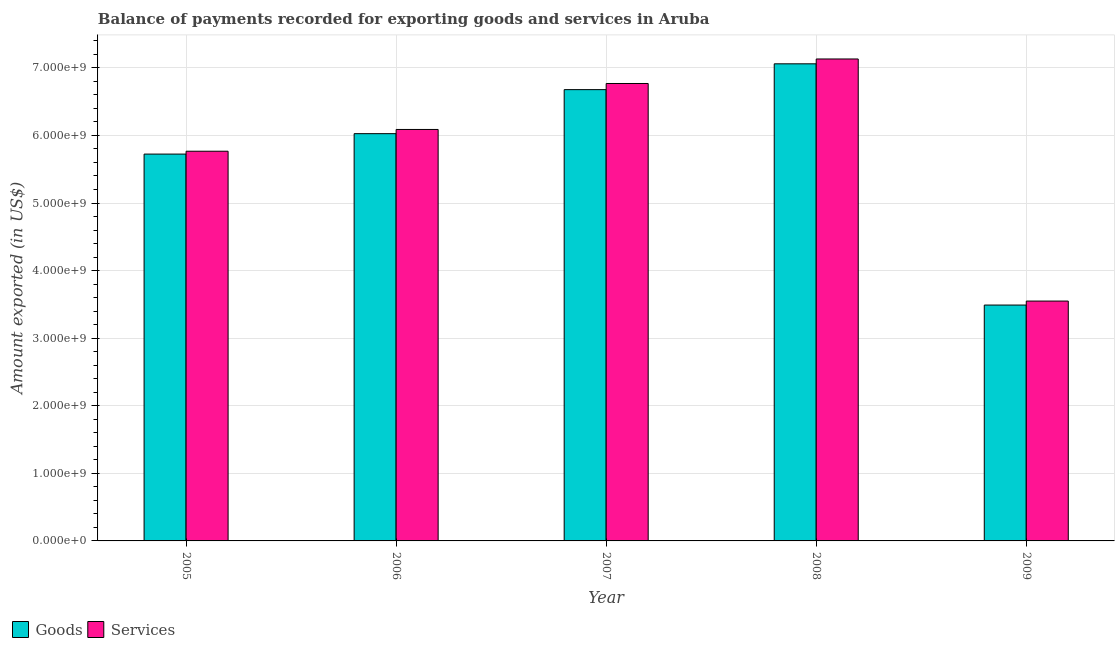How many groups of bars are there?
Give a very brief answer. 5. What is the label of the 3rd group of bars from the left?
Give a very brief answer. 2007. In how many cases, is the number of bars for a given year not equal to the number of legend labels?
Your answer should be compact. 0. What is the amount of services exported in 2008?
Give a very brief answer. 7.13e+09. Across all years, what is the maximum amount of services exported?
Your answer should be compact. 7.13e+09. Across all years, what is the minimum amount of services exported?
Ensure brevity in your answer.  3.55e+09. In which year was the amount of services exported minimum?
Your response must be concise. 2009. What is the total amount of goods exported in the graph?
Ensure brevity in your answer.  2.90e+1. What is the difference between the amount of goods exported in 2005 and that in 2006?
Your answer should be compact. -3.02e+08. What is the difference between the amount of services exported in 2005 and the amount of goods exported in 2008?
Provide a short and direct response. -1.37e+09. What is the average amount of goods exported per year?
Make the answer very short. 5.80e+09. In the year 2007, what is the difference between the amount of services exported and amount of goods exported?
Offer a very short reply. 0. What is the ratio of the amount of goods exported in 2005 to that in 2006?
Ensure brevity in your answer.  0.95. Is the amount of goods exported in 2008 less than that in 2009?
Provide a short and direct response. No. What is the difference between the highest and the second highest amount of goods exported?
Your answer should be very brief. 3.82e+08. What is the difference between the highest and the lowest amount of services exported?
Make the answer very short. 3.58e+09. In how many years, is the amount of services exported greater than the average amount of services exported taken over all years?
Offer a terse response. 3. Is the sum of the amount of goods exported in 2007 and 2009 greater than the maximum amount of services exported across all years?
Your response must be concise. Yes. What does the 2nd bar from the left in 2008 represents?
Keep it short and to the point. Services. What does the 1st bar from the right in 2005 represents?
Keep it short and to the point. Services. How many bars are there?
Your answer should be very brief. 10. Are all the bars in the graph horizontal?
Provide a succinct answer. No. What is the difference between two consecutive major ticks on the Y-axis?
Your answer should be very brief. 1.00e+09. Are the values on the major ticks of Y-axis written in scientific E-notation?
Offer a terse response. Yes. Does the graph contain any zero values?
Provide a short and direct response. No. Does the graph contain grids?
Provide a succinct answer. Yes. Where does the legend appear in the graph?
Offer a very short reply. Bottom left. What is the title of the graph?
Make the answer very short. Balance of payments recorded for exporting goods and services in Aruba. Does "Private creditors" appear as one of the legend labels in the graph?
Offer a terse response. No. What is the label or title of the X-axis?
Your answer should be very brief. Year. What is the label or title of the Y-axis?
Make the answer very short. Amount exported (in US$). What is the Amount exported (in US$) of Goods in 2005?
Offer a very short reply. 5.72e+09. What is the Amount exported (in US$) in Services in 2005?
Ensure brevity in your answer.  5.77e+09. What is the Amount exported (in US$) of Goods in 2006?
Your answer should be very brief. 6.03e+09. What is the Amount exported (in US$) of Services in 2006?
Your response must be concise. 6.09e+09. What is the Amount exported (in US$) of Goods in 2007?
Your response must be concise. 6.68e+09. What is the Amount exported (in US$) in Services in 2007?
Make the answer very short. 6.77e+09. What is the Amount exported (in US$) of Goods in 2008?
Keep it short and to the point. 7.06e+09. What is the Amount exported (in US$) in Services in 2008?
Provide a succinct answer. 7.13e+09. What is the Amount exported (in US$) in Goods in 2009?
Give a very brief answer. 3.49e+09. What is the Amount exported (in US$) in Services in 2009?
Your response must be concise. 3.55e+09. Across all years, what is the maximum Amount exported (in US$) in Goods?
Give a very brief answer. 7.06e+09. Across all years, what is the maximum Amount exported (in US$) of Services?
Ensure brevity in your answer.  7.13e+09. Across all years, what is the minimum Amount exported (in US$) of Goods?
Your response must be concise. 3.49e+09. Across all years, what is the minimum Amount exported (in US$) in Services?
Offer a very short reply. 3.55e+09. What is the total Amount exported (in US$) of Goods in the graph?
Your response must be concise. 2.90e+1. What is the total Amount exported (in US$) of Services in the graph?
Ensure brevity in your answer.  2.93e+1. What is the difference between the Amount exported (in US$) of Goods in 2005 and that in 2006?
Offer a very short reply. -3.02e+08. What is the difference between the Amount exported (in US$) of Services in 2005 and that in 2006?
Provide a short and direct response. -3.22e+08. What is the difference between the Amount exported (in US$) in Goods in 2005 and that in 2007?
Ensure brevity in your answer.  -9.54e+08. What is the difference between the Amount exported (in US$) of Services in 2005 and that in 2007?
Provide a succinct answer. -1.00e+09. What is the difference between the Amount exported (in US$) of Goods in 2005 and that in 2008?
Keep it short and to the point. -1.34e+09. What is the difference between the Amount exported (in US$) of Services in 2005 and that in 2008?
Your answer should be very brief. -1.37e+09. What is the difference between the Amount exported (in US$) of Goods in 2005 and that in 2009?
Provide a succinct answer. 2.23e+09. What is the difference between the Amount exported (in US$) in Services in 2005 and that in 2009?
Give a very brief answer. 2.22e+09. What is the difference between the Amount exported (in US$) in Goods in 2006 and that in 2007?
Keep it short and to the point. -6.52e+08. What is the difference between the Amount exported (in US$) of Services in 2006 and that in 2007?
Provide a short and direct response. -6.80e+08. What is the difference between the Amount exported (in US$) in Goods in 2006 and that in 2008?
Your answer should be very brief. -1.03e+09. What is the difference between the Amount exported (in US$) in Services in 2006 and that in 2008?
Your answer should be very brief. -1.04e+09. What is the difference between the Amount exported (in US$) in Goods in 2006 and that in 2009?
Offer a terse response. 2.54e+09. What is the difference between the Amount exported (in US$) in Services in 2006 and that in 2009?
Make the answer very short. 2.54e+09. What is the difference between the Amount exported (in US$) in Goods in 2007 and that in 2008?
Ensure brevity in your answer.  -3.82e+08. What is the difference between the Amount exported (in US$) of Services in 2007 and that in 2008?
Your response must be concise. -3.63e+08. What is the difference between the Amount exported (in US$) of Goods in 2007 and that in 2009?
Your response must be concise. 3.19e+09. What is the difference between the Amount exported (in US$) in Services in 2007 and that in 2009?
Provide a succinct answer. 3.22e+09. What is the difference between the Amount exported (in US$) of Goods in 2008 and that in 2009?
Provide a short and direct response. 3.57e+09. What is the difference between the Amount exported (in US$) of Services in 2008 and that in 2009?
Provide a short and direct response. 3.58e+09. What is the difference between the Amount exported (in US$) of Goods in 2005 and the Amount exported (in US$) of Services in 2006?
Provide a succinct answer. -3.64e+08. What is the difference between the Amount exported (in US$) in Goods in 2005 and the Amount exported (in US$) in Services in 2007?
Give a very brief answer. -1.04e+09. What is the difference between the Amount exported (in US$) of Goods in 2005 and the Amount exported (in US$) of Services in 2008?
Keep it short and to the point. -1.41e+09. What is the difference between the Amount exported (in US$) in Goods in 2005 and the Amount exported (in US$) in Services in 2009?
Keep it short and to the point. 2.17e+09. What is the difference between the Amount exported (in US$) of Goods in 2006 and the Amount exported (in US$) of Services in 2007?
Keep it short and to the point. -7.42e+08. What is the difference between the Amount exported (in US$) of Goods in 2006 and the Amount exported (in US$) of Services in 2008?
Keep it short and to the point. -1.11e+09. What is the difference between the Amount exported (in US$) of Goods in 2006 and the Amount exported (in US$) of Services in 2009?
Offer a very short reply. 2.48e+09. What is the difference between the Amount exported (in US$) in Goods in 2007 and the Amount exported (in US$) in Services in 2008?
Keep it short and to the point. -4.54e+08. What is the difference between the Amount exported (in US$) in Goods in 2007 and the Amount exported (in US$) in Services in 2009?
Your answer should be compact. 3.13e+09. What is the difference between the Amount exported (in US$) of Goods in 2008 and the Amount exported (in US$) of Services in 2009?
Your answer should be very brief. 3.51e+09. What is the average Amount exported (in US$) in Goods per year?
Keep it short and to the point. 5.80e+09. What is the average Amount exported (in US$) of Services per year?
Your answer should be compact. 5.86e+09. In the year 2005, what is the difference between the Amount exported (in US$) of Goods and Amount exported (in US$) of Services?
Provide a succinct answer. -4.24e+07. In the year 2006, what is the difference between the Amount exported (in US$) of Goods and Amount exported (in US$) of Services?
Offer a very short reply. -6.22e+07. In the year 2007, what is the difference between the Amount exported (in US$) of Goods and Amount exported (in US$) of Services?
Your answer should be compact. -9.08e+07. In the year 2008, what is the difference between the Amount exported (in US$) in Goods and Amount exported (in US$) in Services?
Provide a succinct answer. -7.18e+07. In the year 2009, what is the difference between the Amount exported (in US$) of Goods and Amount exported (in US$) of Services?
Provide a succinct answer. -5.91e+07. What is the ratio of the Amount exported (in US$) in Goods in 2005 to that in 2006?
Provide a succinct answer. 0.95. What is the ratio of the Amount exported (in US$) of Services in 2005 to that in 2006?
Offer a terse response. 0.95. What is the ratio of the Amount exported (in US$) in Goods in 2005 to that in 2007?
Provide a short and direct response. 0.86. What is the ratio of the Amount exported (in US$) of Services in 2005 to that in 2007?
Offer a terse response. 0.85. What is the ratio of the Amount exported (in US$) of Goods in 2005 to that in 2008?
Offer a very short reply. 0.81. What is the ratio of the Amount exported (in US$) in Services in 2005 to that in 2008?
Ensure brevity in your answer.  0.81. What is the ratio of the Amount exported (in US$) of Goods in 2005 to that in 2009?
Keep it short and to the point. 1.64. What is the ratio of the Amount exported (in US$) in Services in 2005 to that in 2009?
Provide a short and direct response. 1.62. What is the ratio of the Amount exported (in US$) of Goods in 2006 to that in 2007?
Give a very brief answer. 0.9. What is the ratio of the Amount exported (in US$) of Services in 2006 to that in 2007?
Your answer should be compact. 0.9. What is the ratio of the Amount exported (in US$) of Goods in 2006 to that in 2008?
Provide a succinct answer. 0.85. What is the ratio of the Amount exported (in US$) in Services in 2006 to that in 2008?
Provide a short and direct response. 0.85. What is the ratio of the Amount exported (in US$) of Goods in 2006 to that in 2009?
Your response must be concise. 1.73. What is the ratio of the Amount exported (in US$) in Services in 2006 to that in 2009?
Keep it short and to the point. 1.72. What is the ratio of the Amount exported (in US$) of Goods in 2007 to that in 2008?
Your response must be concise. 0.95. What is the ratio of the Amount exported (in US$) of Services in 2007 to that in 2008?
Ensure brevity in your answer.  0.95. What is the ratio of the Amount exported (in US$) in Goods in 2007 to that in 2009?
Ensure brevity in your answer.  1.91. What is the ratio of the Amount exported (in US$) of Services in 2007 to that in 2009?
Offer a very short reply. 1.91. What is the ratio of the Amount exported (in US$) of Goods in 2008 to that in 2009?
Provide a short and direct response. 2.02. What is the ratio of the Amount exported (in US$) of Services in 2008 to that in 2009?
Your answer should be very brief. 2.01. What is the difference between the highest and the second highest Amount exported (in US$) of Goods?
Make the answer very short. 3.82e+08. What is the difference between the highest and the second highest Amount exported (in US$) in Services?
Your response must be concise. 3.63e+08. What is the difference between the highest and the lowest Amount exported (in US$) of Goods?
Offer a very short reply. 3.57e+09. What is the difference between the highest and the lowest Amount exported (in US$) in Services?
Your response must be concise. 3.58e+09. 